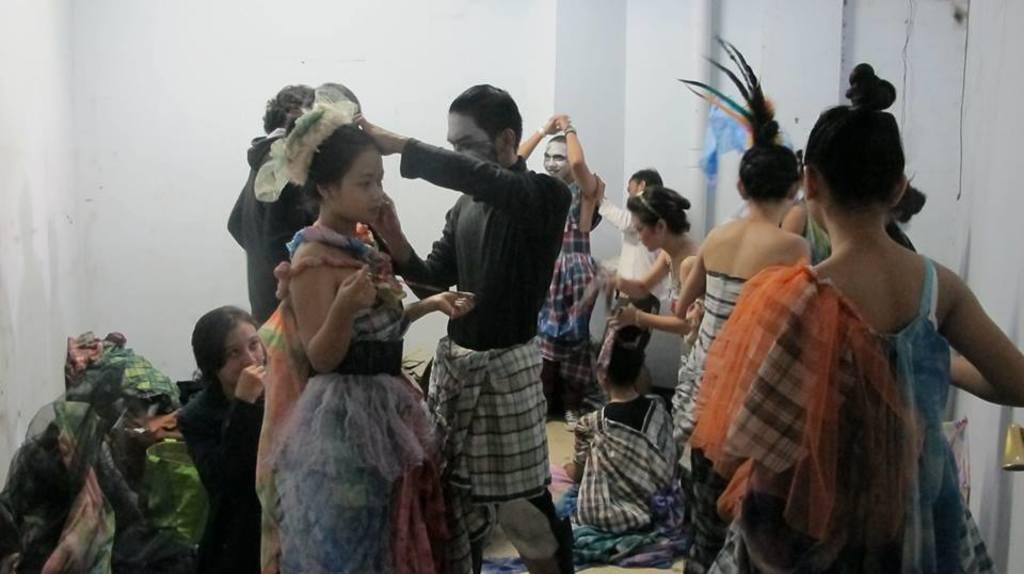How many people are in the image? There is a group of people in the image. What are the people in the image doing? The people are standing. What are the people wearing in the image? The people are wearing different costumes. What colors can be seen on the costumes? The costumes are in different colors. What can be found on the floor in the image? There are objects on the floor in the image. What is the color of the wall in the image? There is a white wall in the image. What is the effect of the kiss on the class in the image? There is no kiss or class present in the image. 